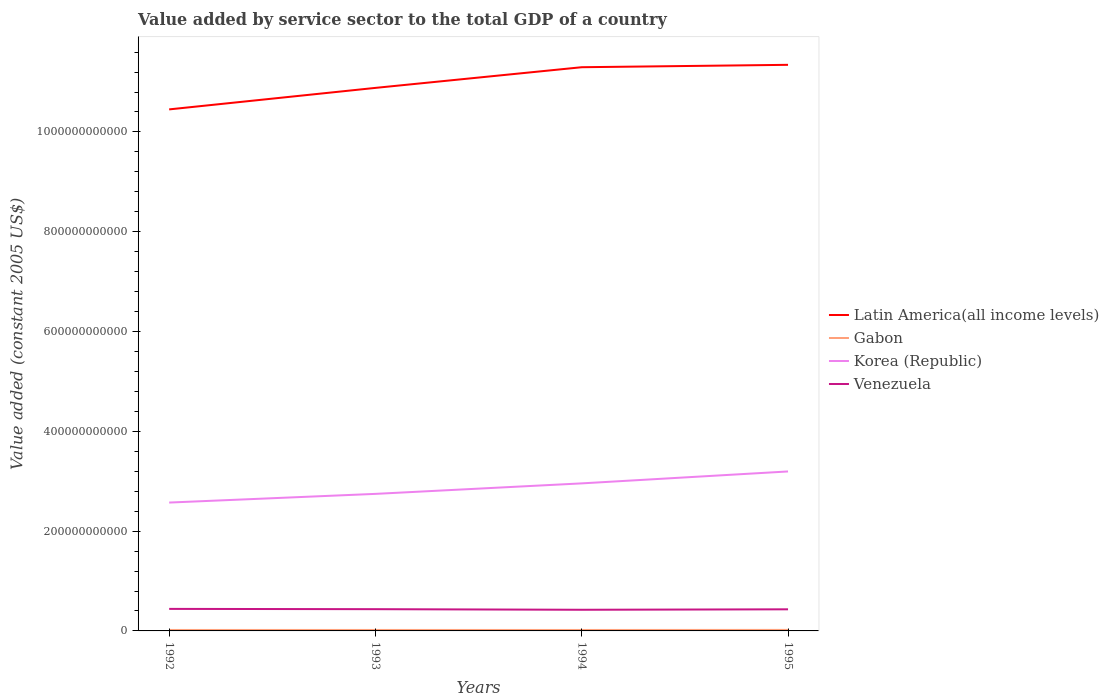Does the line corresponding to Gabon intersect with the line corresponding to Venezuela?
Keep it short and to the point. No. Across all years, what is the maximum value added by service sector in Korea (Republic)?
Provide a short and direct response. 2.57e+11. What is the total value added by service sector in Gabon in the graph?
Provide a succinct answer. 3.16e+06. What is the difference between the highest and the second highest value added by service sector in Latin America(all income levels)?
Your response must be concise. 8.93e+1. Is the value added by service sector in Latin America(all income levels) strictly greater than the value added by service sector in Venezuela over the years?
Make the answer very short. No. How many lines are there?
Your response must be concise. 4. What is the difference between two consecutive major ticks on the Y-axis?
Make the answer very short. 2.00e+11. Does the graph contain grids?
Make the answer very short. No. How are the legend labels stacked?
Ensure brevity in your answer.  Vertical. What is the title of the graph?
Make the answer very short. Value added by service sector to the total GDP of a country. Does "Mexico" appear as one of the legend labels in the graph?
Your answer should be compact. No. What is the label or title of the X-axis?
Provide a short and direct response. Years. What is the label or title of the Y-axis?
Your response must be concise. Value added (constant 2005 US$). What is the Value added (constant 2005 US$) in Latin America(all income levels) in 1992?
Give a very brief answer. 1.05e+12. What is the Value added (constant 2005 US$) in Gabon in 1992?
Your response must be concise. 1.92e+09. What is the Value added (constant 2005 US$) in Korea (Republic) in 1992?
Make the answer very short. 2.57e+11. What is the Value added (constant 2005 US$) of Venezuela in 1992?
Keep it short and to the point. 4.42e+1. What is the Value added (constant 2005 US$) in Latin America(all income levels) in 1993?
Provide a short and direct response. 1.09e+12. What is the Value added (constant 2005 US$) of Gabon in 1993?
Give a very brief answer. 1.95e+09. What is the Value added (constant 2005 US$) of Korea (Republic) in 1993?
Your answer should be very brief. 2.75e+11. What is the Value added (constant 2005 US$) in Venezuela in 1993?
Your answer should be compact. 4.36e+1. What is the Value added (constant 2005 US$) in Latin America(all income levels) in 1994?
Offer a very short reply. 1.13e+12. What is the Value added (constant 2005 US$) of Gabon in 1994?
Give a very brief answer. 1.92e+09. What is the Value added (constant 2005 US$) of Korea (Republic) in 1994?
Make the answer very short. 2.96e+11. What is the Value added (constant 2005 US$) in Venezuela in 1994?
Ensure brevity in your answer.  4.24e+1. What is the Value added (constant 2005 US$) in Latin America(all income levels) in 1995?
Your answer should be very brief. 1.13e+12. What is the Value added (constant 2005 US$) of Gabon in 1995?
Offer a very short reply. 2.03e+09. What is the Value added (constant 2005 US$) of Korea (Republic) in 1995?
Your answer should be very brief. 3.20e+11. What is the Value added (constant 2005 US$) in Venezuela in 1995?
Ensure brevity in your answer.  4.33e+1. Across all years, what is the maximum Value added (constant 2005 US$) of Latin America(all income levels)?
Ensure brevity in your answer.  1.13e+12. Across all years, what is the maximum Value added (constant 2005 US$) of Gabon?
Ensure brevity in your answer.  2.03e+09. Across all years, what is the maximum Value added (constant 2005 US$) of Korea (Republic)?
Ensure brevity in your answer.  3.20e+11. Across all years, what is the maximum Value added (constant 2005 US$) in Venezuela?
Your response must be concise. 4.42e+1. Across all years, what is the minimum Value added (constant 2005 US$) of Latin America(all income levels)?
Your answer should be very brief. 1.05e+12. Across all years, what is the minimum Value added (constant 2005 US$) of Gabon?
Your response must be concise. 1.92e+09. Across all years, what is the minimum Value added (constant 2005 US$) in Korea (Republic)?
Give a very brief answer. 2.57e+11. Across all years, what is the minimum Value added (constant 2005 US$) in Venezuela?
Your answer should be very brief. 4.24e+1. What is the total Value added (constant 2005 US$) in Latin America(all income levels) in the graph?
Your answer should be very brief. 4.40e+12. What is the total Value added (constant 2005 US$) of Gabon in the graph?
Ensure brevity in your answer.  7.81e+09. What is the total Value added (constant 2005 US$) in Korea (Republic) in the graph?
Offer a very short reply. 1.15e+12. What is the total Value added (constant 2005 US$) in Venezuela in the graph?
Offer a very short reply. 1.73e+11. What is the difference between the Value added (constant 2005 US$) in Latin America(all income levels) in 1992 and that in 1993?
Provide a succinct answer. -4.31e+1. What is the difference between the Value added (constant 2005 US$) of Gabon in 1992 and that in 1993?
Make the answer very short. -2.85e+07. What is the difference between the Value added (constant 2005 US$) of Korea (Republic) in 1992 and that in 1993?
Keep it short and to the point. -1.74e+1. What is the difference between the Value added (constant 2005 US$) in Venezuela in 1992 and that in 1993?
Your response must be concise. 5.81e+08. What is the difference between the Value added (constant 2005 US$) in Latin America(all income levels) in 1992 and that in 1994?
Ensure brevity in your answer.  -8.45e+1. What is the difference between the Value added (constant 2005 US$) in Gabon in 1992 and that in 1994?
Your answer should be very brief. 3.16e+06. What is the difference between the Value added (constant 2005 US$) of Korea (Republic) in 1992 and that in 1994?
Keep it short and to the point. -3.85e+1. What is the difference between the Value added (constant 2005 US$) of Venezuela in 1992 and that in 1994?
Give a very brief answer. 1.77e+09. What is the difference between the Value added (constant 2005 US$) in Latin America(all income levels) in 1992 and that in 1995?
Your answer should be compact. -8.93e+1. What is the difference between the Value added (constant 2005 US$) in Gabon in 1992 and that in 1995?
Offer a terse response. -1.10e+08. What is the difference between the Value added (constant 2005 US$) of Korea (Republic) in 1992 and that in 1995?
Make the answer very short. -6.24e+1. What is the difference between the Value added (constant 2005 US$) of Venezuela in 1992 and that in 1995?
Offer a terse response. 8.60e+08. What is the difference between the Value added (constant 2005 US$) of Latin America(all income levels) in 1993 and that in 1994?
Give a very brief answer. -4.14e+1. What is the difference between the Value added (constant 2005 US$) of Gabon in 1993 and that in 1994?
Keep it short and to the point. 3.16e+07. What is the difference between the Value added (constant 2005 US$) in Korea (Republic) in 1993 and that in 1994?
Provide a short and direct response. -2.10e+1. What is the difference between the Value added (constant 2005 US$) of Venezuela in 1993 and that in 1994?
Make the answer very short. 1.19e+09. What is the difference between the Value added (constant 2005 US$) of Latin America(all income levels) in 1993 and that in 1995?
Your answer should be compact. -4.62e+1. What is the difference between the Value added (constant 2005 US$) in Gabon in 1993 and that in 1995?
Keep it short and to the point. -8.12e+07. What is the difference between the Value added (constant 2005 US$) of Korea (Republic) in 1993 and that in 1995?
Make the answer very short. -4.49e+1. What is the difference between the Value added (constant 2005 US$) in Venezuela in 1993 and that in 1995?
Make the answer very short. 2.79e+08. What is the difference between the Value added (constant 2005 US$) of Latin America(all income levels) in 1994 and that in 1995?
Ensure brevity in your answer.  -4.79e+09. What is the difference between the Value added (constant 2005 US$) of Gabon in 1994 and that in 1995?
Your answer should be very brief. -1.13e+08. What is the difference between the Value added (constant 2005 US$) in Korea (Republic) in 1994 and that in 1995?
Offer a terse response. -2.39e+1. What is the difference between the Value added (constant 2005 US$) in Venezuela in 1994 and that in 1995?
Offer a very short reply. -9.11e+08. What is the difference between the Value added (constant 2005 US$) of Latin America(all income levels) in 1992 and the Value added (constant 2005 US$) of Gabon in 1993?
Your answer should be very brief. 1.04e+12. What is the difference between the Value added (constant 2005 US$) of Latin America(all income levels) in 1992 and the Value added (constant 2005 US$) of Korea (Republic) in 1993?
Provide a succinct answer. 7.71e+11. What is the difference between the Value added (constant 2005 US$) in Latin America(all income levels) in 1992 and the Value added (constant 2005 US$) in Venezuela in 1993?
Your answer should be compact. 1.00e+12. What is the difference between the Value added (constant 2005 US$) in Gabon in 1992 and the Value added (constant 2005 US$) in Korea (Republic) in 1993?
Make the answer very short. -2.73e+11. What is the difference between the Value added (constant 2005 US$) of Gabon in 1992 and the Value added (constant 2005 US$) of Venezuela in 1993?
Your answer should be very brief. -4.17e+1. What is the difference between the Value added (constant 2005 US$) of Korea (Republic) in 1992 and the Value added (constant 2005 US$) of Venezuela in 1993?
Offer a very short reply. 2.14e+11. What is the difference between the Value added (constant 2005 US$) of Latin America(all income levels) in 1992 and the Value added (constant 2005 US$) of Gabon in 1994?
Provide a short and direct response. 1.04e+12. What is the difference between the Value added (constant 2005 US$) of Latin America(all income levels) in 1992 and the Value added (constant 2005 US$) of Korea (Republic) in 1994?
Your answer should be very brief. 7.49e+11. What is the difference between the Value added (constant 2005 US$) of Latin America(all income levels) in 1992 and the Value added (constant 2005 US$) of Venezuela in 1994?
Ensure brevity in your answer.  1.00e+12. What is the difference between the Value added (constant 2005 US$) of Gabon in 1992 and the Value added (constant 2005 US$) of Korea (Republic) in 1994?
Offer a terse response. -2.94e+11. What is the difference between the Value added (constant 2005 US$) of Gabon in 1992 and the Value added (constant 2005 US$) of Venezuela in 1994?
Your response must be concise. -4.05e+1. What is the difference between the Value added (constant 2005 US$) of Korea (Republic) in 1992 and the Value added (constant 2005 US$) of Venezuela in 1994?
Make the answer very short. 2.15e+11. What is the difference between the Value added (constant 2005 US$) in Latin America(all income levels) in 1992 and the Value added (constant 2005 US$) in Gabon in 1995?
Your answer should be very brief. 1.04e+12. What is the difference between the Value added (constant 2005 US$) of Latin America(all income levels) in 1992 and the Value added (constant 2005 US$) of Korea (Republic) in 1995?
Your answer should be very brief. 7.26e+11. What is the difference between the Value added (constant 2005 US$) of Latin America(all income levels) in 1992 and the Value added (constant 2005 US$) of Venezuela in 1995?
Give a very brief answer. 1.00e+12. What is the difference between the Value added (constant 2005 US$) of Gabon in 1992 and the Value added (constant 2005 US$) of Korea (Republic) in 1995?
Offer a very short reply. -3.18e+11. What is the difference between the Value added (constant 2005 US$) in Gabon in 1992 and the Value added (constant 2005 US$) in Venezuela in 1995?
Provide a short and direct response. -4.14e+1. What is the difference between the Value added (constant 2005 US$) of Korea (Republic) in 1992 and the Value added (constant 2005 US$) of Venezuela in 1995?
Offer a terse response. 2.14e+11. What is the difference between the Value added (constant 2005 US$) of Latin America(all income levels) in 1993 and the Value added (constant 2005 US$) of Gabon in 1994?
Provide a succinct answer. 1.09e+12. What is the difference between the Value added (constant 2005 US$) in Latin America(all income levels) in 1993 and the Value added (constant 2005 US$) in Korea (Republic) in 1994?
Offer a very short reply. 7.93e+11. What is the difference between the Value added (constant 2005 US$) of Latin America(all income levels) in 1993 and the Value added (constant 2005 US$) of Venezuela in 1994?
Offer a terse response. 1.05e+12. What is the difference between the Value added (constant 2005 US$) of Gabon in 1993 and the Value added (constant 2005 US$) of Korea (Republic) in 1994?
Provide a short and direct response. -2.94e+11. What is the difference between the Value added (constant 2005 US$) of Gabon in 1993 and the Value added (constant 2005 US$) of Venezuela in 1994?
Give a very brief answer. -4.04e+1. What is the difference between the Value added (constant 2005 US$) of Korea (Republic) in 1993 and the Value added (constant 2005 US$) of Venezuela in 1994?
Give a very brief answer. 2.32e+11. What is the difference between the Value added (constant 2005 US$) of Latin America(all income levels) in 1993 and the Value added (constant 2005 US$) of Gabon in 1995?
Make the answer very short. 1.09e+12. What is the difference between the Value added (constant 2005 US$) of Latin America(all income levels) in 1993 and the Value added (constant 2005 US$) of Korea (Republic) in 1995?
Ensure brevity in your answer.  7.69e+11. What is the difference between the Value added (constant 2005 US$) in Latin America(all income levels) in 1993 and the Value added (constant 2005 US$) in Venezuela in 1995?
Your response must be concise. 1.04e+12. What is the difference between the Value added (constant 2005 US$) in Gabon in 1993 and the Value added (constant 2005 US$) in Korea (Republic) in 1995?
Offer a terse response. -3.18e+11. What is the difference between the Value added (constant 2005 US$) in Gabon in 1993 and the Value added (constant 2005 US$) in Venezuela in 1995?
Offer a very short reply. -4.14e+1. What is the difference between the Value added (constant 2005 US$) of Korea (Republic) in 1993 and the Value added (constant 2005 US$) of Venezuela in 1995?
Your response must be concise. 2.31e+11. What is the difference between the Value added (constant 2005 US$) in Latin America(all income levels) in 1994 and the Value added (constant 2005 US$) in Gabon in 1995?
Make the answer very short. 1.13e+12. What is the difference between the Value added (constant 2005 US$) of Latin America(all income levels) in 1994 and the Value added (constant 2005 US$) of Korea (Republic) in 1995?
Make the answer very short. 8.10e+11. What is the difference between the Value added (constant 2005 US$) of Latin America(all income levels) in 1994 and the Value added (constant 2005 US$) of Venezuela in 1995?
Your response must be concise. 1.09e+12. What is the difference between the Value added (constant 2005 US$) of Gabon in 1994 and the Value added (constant 2005 US$) of Korea (Republic) in 1995?
Your answer should be compact. -3.18e+11. What is the difference between the Value added (constant 2005 US$) in Gabon in 1994 and the Value added (constant 2005 US$) in Venezuela in 1995?
Offer a very short reply. -4.14e+1. What is the difference between the Value added (constant 2005 US$) in Korea (Republic) in 1994 and the Value added (constant 2005 US$) in Venezuela in 1995?
Ensure brevity in your answer.  2.52e+11. What is the average Value added (constant 2005 US$) of Latin America(all income levels) per year?
Offer a terse response. 1.10e+12. What is the average Value added (constant 2005 US$) of Gabon per year?
Provide a short and direct response. 1.95e+09. What is the average Value added (constant 2005 US$) in Korea (Republic) per year?
Keep it short and to the point. 2.87e+11. What is the average Value added (constant 2005 US$) in Venezuela per year?
Your answer should be compact. 4.34e+1. In the year 1992, what is the difference between the Value added (constant 2005 US$) of Latin America(all income levels) and Value added (constant 2005 US$) of Gabon?
Your response must be concise. 1.04e+12. In the year 1992, what is the difference between the Value added (constant 2005 US$) of Latin America(all income levels) and Value added (constant 2005 US$) of Korea (Republic)?
Ensure brevity in your answer.  7.88e+11. In the year 1992, what is the difference between the Value added (constant 2005 US$) of Latin America(all income levels) and Value added (constant 2005 US$) of Venezuela?
Provide a short and direct response. 1.00e+12. In the year 1992, what is the difference between the Value added (constant 2005 US$) in Gabon and Value added (constant 2005 US$) in Korea (Republic)?
Give a very brief answer. -2.55e+11. In the year 1992, what is the difference between the Value added (constant 2005 US$) in Gabon and Value added (constant 2005 US$) in Venezuela?
Give a very brief answer. -4.22e+1. In the year 1992, what is the difference between the Value added (constant 2005 US$) of Korea (Republic) and Value added (constant 2005 US$) of Venezuela?
Provide a succinct answer. 2.13e+11. In the year 1993, what is the difference between the Value added (constant 2005 US$) in Latin America(all income levels) and Value added (constant 2005 US$) in Gabon?
Your response must be concise. 1.09e+12. In the year 1993, what is the difference between the Value added (constant 2005 US$) in Latin America(all income levels) and Value added (constant 2005 US$) in Korea (Republic)?
Make the answer very short. 8.14e+11. In the year 1993, what is the difference between the Value added (constant 2005 US$) of Latin America(all income levels) and Value added (constant 2005 US$) of Venezuela?
Offer a terse response. 1.04e+12. In the year 1993, what is the difference between the Value added (constant 2005 US$) in Gabon and Value added (constant 2005 US$) in Korea (Republic)?
Offer a very short reply. -2.73e+11. In the year 1993, what is the difference between the Value added (constant 2005 US$) of Gabon and Value added (constant 2005 US$) of Venezuela?
Give a very brief answer. -4.16e+1. In the year 1993, what is the difference between the Value added (constant 2005 US$) of Korea (Republic) and Value added (constant 2005 US$) of Venezuela?
Provide a short and direct response. 2.31e+11. In the year 1994, what is the difference between the Value added (constant 2005 US$) in Latin America(all income levels) and Value added (constant 2005 US$) in Gabon?
Ensure brevity in your answer.  1.13e+12. In the year 1994, what is the difference between the Value added (constant 2005 US$) in Latin America(all income levels) and Value added (constant 2005 US$) in Korea (Republic)?
Offer a very short reply. 8.34e+11. In the year 1994, what is the difference between the Value added (constant 2005 US$) in Latin America(all income levels) and Value added (constant 2005 US$) in Venezuela?
Give a very brief answer. 1.09e+12. In the year 1994, what is the difference between the Value added (constant 2005 US$) of Gabon and Value added (constant 2005 US$) of Korea (Republic)?
Offer a terse response. -2.94e+11. In the year 1994, what is the difference between the Value added (constant 2005 US$) in Gabon and Value added (constant 2005 US$) in Venezuela?
Your answer should be very brief. -4.05e+1. In the year 1994, what is the difference between the Value added (constant 2005 US$) in Korea (Republic) and Value added (constant 2005 US$) in Venezuela?
Your answer should be compact. 2.53e+11. In the year 1995, what is the difference between the Value added (constant 2005 US$) in Latin America(all income levels) and Value added (constant 2005 US$) in Gabon?
Provide a short and direct response. 1.13e+12. In the year 1995, what is the difference between the Value added (constant 2005 US$) in Latin America(all income levels) and Value added (constant 2005 US$) in Korea (Republic)?
Your response must be concise. 8.15e+11. In the year 1995, what is the difference between the Value added (constant 2005 US$) in Latin America(all income levels) and Value added (constant 2005 US$) in Venezuela?
Give a very brief answer. 1.09e+12. In the year 1995, what is the difference between the Value added (constant 2005 US$) of Gabon and Value added (constant 2005 US$) of Korea (Republic)?
Provide a short and direct response. -3.18e+11. In the year 1995, what is the difference between the Value added (constant 2005 US$) in Gabon and Value added (constant 2005 US$) in Venezuela?
Your response must be concise. -4.13e+1. In the year 1995, what is the difference between the Value added (constant 2005 US$) of Korea (Republic) and Value added (constant 2005 US$) of Venezuela?
Offer a terse response. 2.76e+11. What is the ratio of the Value added (constant 2005 US$) of Latin America(all income levels) in 1992 to that in 1993?
Ensure brevity in your answer.  0.96. What is the ratio of the Value added (constant 2005 US$) of Gabon in 1992 to that in 1993?
Make the answer very short. 0.99. What is the ratio of the Value added (constant 2005 US$) in Korea (Republic) in 1992 to that in 1993?
Provide a succinct answer. 0.94. What is the ratio of the Value added (constant 2005 US$) of Venezuela in 1992 to that in 1993?
Give a very brief answer. 1.01. What is the ratio of the Value added (constant 2005 US$) in Latin America(all income levels) in 1992 to that in 1994?
Ensure brevity in your answer.  0.93. What is the ratio of the Value added (constant 2005 US$) of Gabon in 1992 to that in 1994?
Ensure brevity in your answer.  1. What is the ratio of the Value added (constant 2005 US$) of Korea (Republic) in 1992 to that in 1994?
Provide a short and direct response. 0.87. What is the ratio of the Value added (constant 2005 US$) of Venezuela in 1992 to that in 1994?
Make the answer very short. 1.04. What is the ratio of the Value added (constant 2005 US$) in Latin America(all income levels) in 1992 to that in 1995?
Provide a succinct answer. 0.92. What is the ratio of the Value added (constant 2005 US$) in Gabon in 1992 to that in 1995?
Your response must be concise. 0.95. What is the ratio of the Value added (constant 2005 US$) of Korea (Republic) in 1992 to that in 1995?
Provide a succinct answer. 0.8. What is the ratio of the Value added (constant 2005 US$) in Venezuela in 1992 to that in 1995?
Keep it short and to the point. 1.02. What is the ratio of the Value added (constant 2005 US$) of Latin America(all income levels) in 1993 to that in 1994?
Your answer should be very brief. 0.96. What is the ratio of the Value added (constant 2005 US$) in Gabon in 1993 to that in 1994?
Provide a succinct answer. 1.02. What is the ratio of the Value added (constant 2005 US$) of Korea (Republic) in 1993 to that in 1994?
Provide a succinct answer. 0.93. What is the ratio of the Value added (constant 2005 US$) of Venezuela in 1993 to that in 1994?
Provide a short and direct response. 1.03. What is the ratio of the Value added (constant 2005 US$) of Latin America(all income levels) in 1993 to that in 1995?
Make the answer very short. 0.96. What is the ratio of the Value added (constant 2005 US$) of Korea (Republic) in 1993 to that in 1995?
Your answer should be very brief. 0.86. What is the ratio of the Value added (constant 2005 US$) in Gabon in 1994 to that in 1995?
Offer a terse response. 0.94. What is the ratio of the Value added (constant 2005 US$) of Korea (Republic) in 1994 to that in 1995?
Offer a very short reply. 0.93. What is the ratio of the Value added (constant 2005 US$) of Venezuela in 1994 to that in 1995?
Provide a short and direct response. 0.98. What is the difference between the highest and the second highest Value added (constant 2005 US$) of Latin America(all income levels)?
Your response must be concise. 4.79e+09. What is the difference between the highest and the second highest Value added (constant 2005 US$) of Gabon?
Give a very brief answer. 8.12e+07. What is the difference between the highest and the second highest Value added (constant 2005 US$) in Korea (Republic)?
Ensure brevity in your answer.  2.39e+1. What is the difference between the highest and the second highest Value added (constant 2005 US$) in Venezuela?
Make the answer very short. 5.81e+08. What is the difference between the highest and the lowest Value added (constant 2005 US$) in Latin America(all income levels)?
Make the answer very short. 8.93e+1. What is the difference between the highest and the lowest Value added (constant 2005 US$) in Gabon?
Offer a very short reply. 1.13e+08. What is the difference between the highest and the lowest Value added (constant 2005 US$) in Korea (Republic)?
Your response must be concise. 6.24e+1. What is the difference between the highest and the lowest Value added (constant 2005 US$) of Venezuela?
Your answer should be compact. 1.77e+09. 